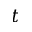<formula> <loc_0><loc_0><loc_500><loc_500>t</formula> 